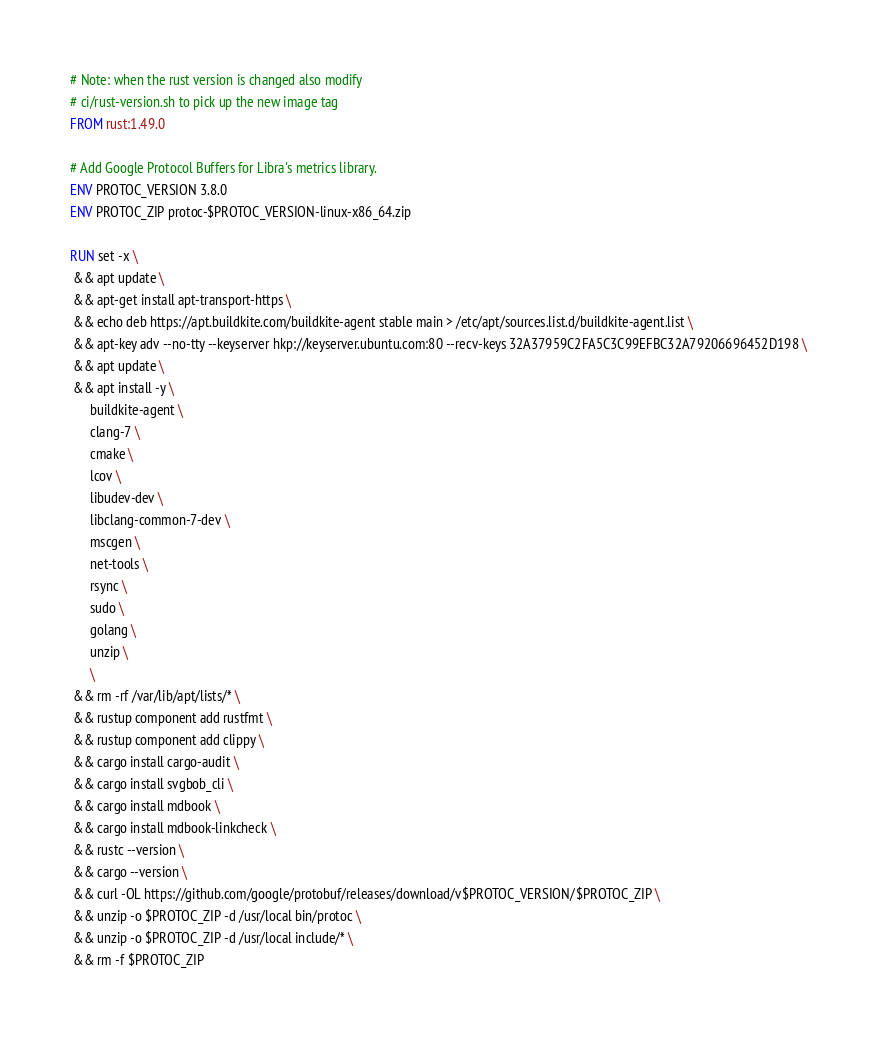Convert code to text. <code><loc_0><loc_0><loc_500><loc_500><_Dockerfile_># Note: when the rust version is changed also modify
# ci/rust-version.sh to pick up the new image tag
FROM rust:1.49.0

# Add Google Protocol Buffers for Libra's metrics library.
ENV PROTOC_VERSION 3.8.0
ENV PROTOC_ZIP protoc-$PROTOC_VERSION-linux-x86_64.zip

RUN set -x \
 && apt update \
 && apt-get install apt-transport-https \
 && echo deb https://apt.buildkite.com/buildkite-agent stable main > /etc/apt/sources.list.d/buildkite-agent.list \
 && apt-key adv --no-tty --keyserver hkp://keyserver.ubuntu.com:80 --recv-keys 32A37959C2FA5C3C99EFBC32A79206696452D198 \
 && apt update \
 && apt install -y \
      buildkite-agent \
      clang-7 \
      cmake \
      lcov \
      libudev-dev \
      libclang-common-7-dev \
      mscgen \
      net-tools \
      rsync \
      sudo \
      golang \
      unzip \
      \
 && rm -rf /var/lib/apt/lists/* \
 && rustup component add rustfmt \
 && rustup component add clippy \
 && cargo install cargo-audit \
 && cargo install svgbob_cli \
 && cargo install mdbook \
 && cargo install mdbook-linkcheck \
 && rustc --version \
 && cargo --version \
 && curl -OL https://github.com/google/protobuf/releases/download/v$PROTOC_VERSION/$PROTOC_ZIP \
 && unzip -o $PROTOC_ZIP -d /usr/local bin/protoc \
 && unzip -o $PROTOC_ZIP -d /usr/local include/* \
 && rm -f $PROTOC_ZIP
</code> 